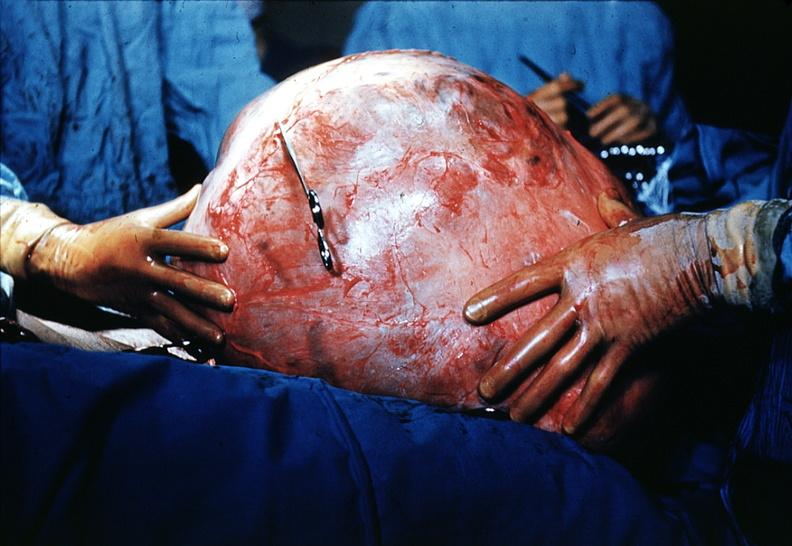s sacrococcygeal teratoma present?
Answer the question using a single word or phrase. No 